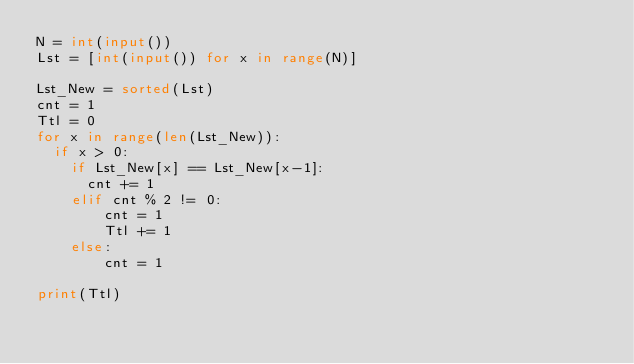<code> <loc_0><loc_0><loc_500><loc_500><_Python_>N = int(input())
Lst = [int(input()) for x in range(N)]

Lst_New = sorted(Lst)
cnt = 1
Ttl = 0
for x in range(len(Lst_New)):
  if x > 0:
    if Lst_New[x] == Lst_New[x-1]:
    	cnt += 1
    elif cnt % 2 != 0:
      	cnt = 1
      	Ttl += 1
    else:
      	cnt = 1
      
print(Ttl)</code> 